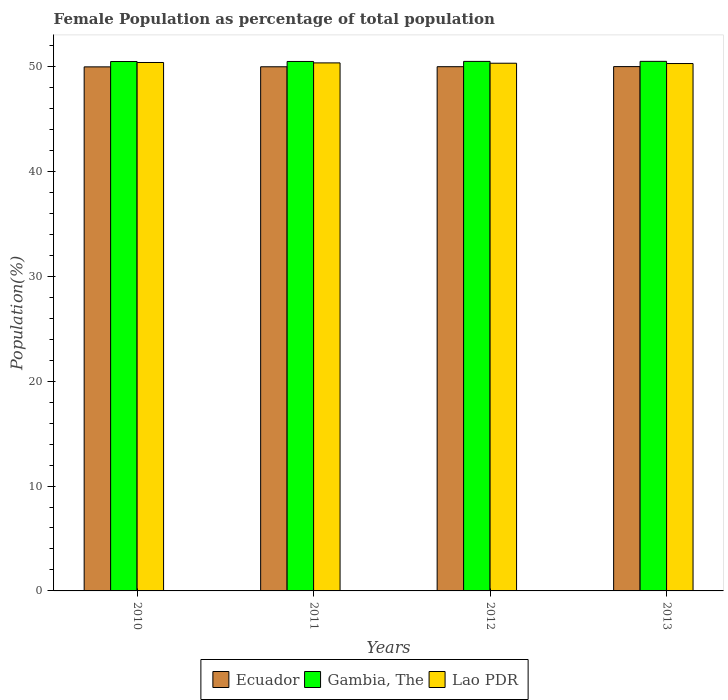How many different coloured bars are there?
Your answer should be very brief. 3. How many bars are there on the 2nd tick from the right?
Offer a terse response. 3. What is the female population in in Ecuador in 2011?
Your response must be concise. 49.98. Across all years, what is the maximum female population in in Ecuador?
Your response must be concise. 49.99. Across all years, what is the minimum female population in in Lao PDR?
Keep it short and to the point. 50.28. In which year was the female population in in Lao PDR maximum?
Your response must be concise. 2010. What is the total female population in in Gambia, The in the graph?
Provide a succinct answer. 201.94. What is the difference between the female population in in Lao PDR in 2010 and that in 2013?
Your response must be concise. 0.1. What is the difference between the female population in in Lao PDR in 2010 and the female population in in Ecuador in 2012?
Provide a succinct answer. 0.4. What is the average female population in in Gambia, The per year?
Your response must be concise. 50.48. In the year 2012, what is the difference between the female population in in Ecuador and female population in in Gambia, The?
Make the answer very short. -0.5. In how many years, is the female population in in Lao PDR greater than 20 %?
Your response must be concise. 4. What is the ratio of the female population in in Lao PDR in 2011 to that in 2012?
Your response must be concise. 1. What is the difference between the highest and the second highest female population in in Lao PDR?
Give a very brief answer. 0.04. What is the difference between the highest and the lowest female population in in Ecuador?
Offer a very short reply. 0.02. What does the 1st bar from the left in 2011 represents?
Provide a succinct answer. Ecuador. What does the 1st bar from the right in 2013 represents?
Keep it short and to the point. Lao PDR. How many bars are there?
Provide a succinct answer. 12. Are all the bars in the graph horizontal?
Keep it short and to the point. No. How many years are there in the graph?
Your response must be concise. 4. What is the difference between two consecutive major ticks on the Y-axis?
Ensure brevity in your answer.  10. Are the values on the major ticks of Y-axis written in scientific E-notation?
Your answer should be compact. No. Does the graph contain any zero values?
Give a very brief answer. No. Does the graph contain grids?
Ensure brevity in your answer.  No. Where does the legend appear in the graph?
Your answer should be very brief. Bottom center. How are the legend labels stacked?
Offer a very short reply. Horizontal. What is the title of the graph?
Give a very brief answer. Female Population as percentage of total population. What is the label or title of the Y-axis?
Provide a short and direct response. Population(%). What is the Population(%) in Ecuador in 2010?
Offer a terse response. 49.97. What is the Population(%) in Gambia, The in 2010?
Your answer should be very brief. 50.48. What is the Population(%) of Lao PDR in 2010?
Your answer should be very brief. 50.38. What is the Population(%) of Ecuador in 2011?
Ensure brevity in your answer.  49.98. What is the Population(%) of Gambia, The in 2011?
Your answer should be very brief. 50.48. What is the Population(%) in Lao PDR in 2011?
Make the answer very short. 50.35. What is the Population(%) of Ecuador in 2012?
Offer a terse response. 49.98. What is the Population(%) in Gambia, The in 2012?
Your response must be concise. 50.49. What is the Population(%) in Lao PDR in 2012?
Your answer should be very brief. 50.31. What is the Population(%) in Ecuador in 2013?
Ensure brevity in your answer.  49.99. What is the Population(%) in Gambia, The in 2013?
Provide a succinct answer. 50.49. What is the Population(%) in Lao PDR in 2013?
Give a very brief answer. 50.28. Across all years, what is the maximum Population(%) in Ecuador?
Offer a very short reply. 49.99. Across all years, what is the maximum Population(%) of Gambia, The?
Your response must be concise. 50.49. Across all years, what is the maximum Population(%) of Lao PDR?
Offer a terse response. 50.38. Across all years, what is the minimum Population(%) in Ecuador?
Ensure brevity in your answer.  49.97. Across all years, what is the minimum Population(%) of Gambia, The?
Make the answer very short. 50.48. Across all years, what is the minimum Population(%) of Lao PDR?
Provide a succinct answer. 50.28. What is the total Population(%) of Ecuador in the graph?
Your response must be concise. 199.92. What is the total Population(%) in Gambia, The in the graph?
Your response must be concise. 201.94. What is the total Population(%) of Lao PDR in the graph?
Ensure brevity in your answer.  201.33. What is the difference between the Population(%) in Ecuador in 2010 and that in 2011?
Keep it short and to the point. -0.01. What is the difference between the Population(%) in Gambia, The in 2010 and that in 2011?
Offer a terse response. -0.01. What is the difference between the Population(%) of Lao PDR in 2010 and that in 2011?
Keep it short and to the point. 0.04. What is the difference between the Population(%) in Ecuador in 2010 and that in 2012?
Offer a terse response. -0.02. What is the difference between the Population(%) in Gambia, The in 2010 and that in 2012?
Your response must be concise. -0.01. What is the difference between the Population(%) of Lao PDR in 2010 and that in 2012?
Keep it short and to the point. 0.07. What is the difference between the Population(%) in Ecuador in 2010 and that in 2013?
Keep it short and to the point. -0.03. What is the difference between the Population(%) of Gambia, The in 2010 and that in 2013?
Your answer should be very brief. -0.02. What is the difference between the Population(%) of Lao PDR in 2010 and that in 2013?
Keep it short and to the point. 0.1. What is the difference between the Population(%) of Ecuador in 2011 and that in 2012?
Give a very brief answer. -0.01. What is the difference between the Population(%) in Gambia, The in 2011 and that in 2012?
Your answer should be very brief. -0.01. What is the difference between the Population(%) in Lao PDR in 2011 and that in 2012?
Offer a terse response. 0.03. What is the difference between the Population(%) in Ecuador in 2011 and that in 2013?
Make the answer very short. -0.02. What is the difference between the Population(%) of Gambia, The in 2011 and that in 2013?
Ensure brevity in your answer.  -0.01. What is the difference between the Population(%) of Lao PDR in 2011 and that in 2013?
Provide a short and direct response. 0.06. What is the difference between the Population(%) in Ecuador in 2012 and that in 2013?
Offer a terse response. -0.01. What is the difference between the Population(%) of Gambia, The in 2012 and that in 2013?
Offer a terse response. -0. What is the difference between the Population(%) in Lao PDR in 2012 and that in 2013?
Your answer should be very brief. 0.03. What is the difference between the Population(%) of Ecuador in 2010 and the Population(%) of Gambia, The in 2011?
Give a very brief answer. -0.52. What is the difference between the Population(%) in Ecuador in 2010 and the Population(%) in Lao PDR in 2011?
Ensure brevity in your answer.  -0.38. What is the difference between the Population(%) in Gambia, The in 2010 and the Population(%) in Lao PDR in 2011?
Offer a terse response. 0.13. What is the difference between the Population(%) in Ecuador in 2010 and the Population(%) in Gambia, The in 2012?
Ensure brevity in your answer.  -0.52. What is the difference between the Population(%) of Ecuador in 2010 and the Population(%) of Lao PDR in 2012?
Ensure brevity in your answer.  -0.35. What is the difference between the Population(%) in Gambia, The in 2010 and the Population(%) in Lao PDR in 2012?
Provide a succinct answer. 0.16. What is the difference between the Population(%) in Ecuador in 2010 and the Population(%) in Gambia, The in 2013?
Your answer should be compact. -0.53. What is the difference between the Population(%) in Ecuador in 2010 and the Population(%) in Lao PDR in 2013?
Make the answer very short. -0.32. What is the difference between the Population(%) of Gambia, The in 2010 and the Population(%) of Lao PDR in 2013?
Give a very brief answer. 0.19. What is the difference between the Population(%) in Ecuador in 2011 and the Population(%) in Gambia, The in 2012?
Offer a terse response. -0.51. What is the difference between the Population(%) in Ecuador in 2011 and the Population(%) in Lao PDR in 2012?
Ensure brevity in your answer.  -0.34. What is the difference between the Population(%) in Gambia, The in 2011 and the Population(%) in Lao PDR in 2012?
Offer a terse response. 0.17. What is the difference between the Population(%) of Ecuador in 2011 and the Population(%) of Gambia, The in 2013?
Ensure brevity in your answer.  -0.52. What is the difference between the Population(%) in Ecuador in 2011 and the Population(%) in Lao PDR in 2013?
Give a very brief answer. -0.31. What is the difference between the Population(%) in Gambia, The in 2011 and the Population(%) in Lao PDR in 2013?
Provide a short and direct response. 0.2. What is the difference between the Population(%) in Ecuador in 2012 and the Population(%) in Gambia, The in 2013?
Your answer should be compact. -0.51. What is the difference between the Population(%) in Ecuador in 2012 and the Population(%) in Lao PDR in 2013?
Ensure brevity in your answer.  -0.3. What is the difference between the Population(%) in Gambia, The in 2012 and the Population(%) in Lao PDR in 2013?
Offer a very short reply. 0.2. What is the average Population(%) in Ecuador per year?
Your answer should be very brief. 49.98. What is the average Population(%) of Gambia, The per year?
Provide a short and direct response. 50.48. What is the average Population(%) of Lao PDR per year?
Your answer should be compact. 50.33. In the year 2010, what is the difference between the Population(%) of Ecuador and Population(%) of Gambia, The?
Your answer should be very brief. -0.51. In the year 2010, what is the difference between the Population(%) in Ecuador and Population(%) in Lao PDR?
Offer a terse response. -0.42. In the year 2010, what is the difference between the Population(%) of Gambia, The and Population(%) of Lao PDR?
Offer a terse response. 0.09. In the year 2011, what is the difference between the Population(%) of Ecuador and Population(%) of Gambia, The?
Ensure brevity in your answer.  -0.51. In the year 2011, what is the difference between the Population(%) of Ecuador and Population(%) of Lao PDR?
Offer a very short reply. -0.37. In the year 2011, what is the difference between the Population(%) in Gambia, The and Population(%) in Lao PDR?
Give a very brief answer. 0.14. In the year 2012, what is the difference between the Population(%) of Ecuador and Population(%) of Gambia, The?
Your response must be concise. -0.5. In the year 2012, what is the difference between the Population(%) of Ecuador and Population(%) of Lao PDR?
Offer a terse response. -0.33. In the year 2012, what is the difference between the Population(%) in Gambia, The and Population(%) in Lao PDR?
Your response must be concise. 0.17. In the year 2013, what is the difference between the Population(%) in Ecuador and Population(%) in Gambia, The?
Your answer should be compact. -0.5. In the year 2013, what is the difference between the Population(%) in Ecuador and Population(%) in Lao PDR?
Offer a very short reply. -0.29. In the year 2013, what is the difference between the Population(%) of Gambia, The and Population(%) of Lao PDR?
Your answer should be very brief. 0.21. What is the ratio of the Population(%) of Gambia, The in 2010 to that in 2012?
Give a very brief answer. 1. What is the ratio of the Population(%) of Lao PDR in 2010 to that in 2012?
Your answer should be very brief. 1. What is the ratio of the Population(%) in Ecuador in 2010 to that in 2013?
Offer a terse response. 1. What is the ratio of the Population(%) of Gambia, The in 2011 to that in 2012?
Keep it short and to the point. 1. What is the ratio of the Population(%) in Ecuador in 2011 to that in 2013?
Keep it short and to the point. 1. What is the ratio of the Population(%) in Gambia, The in 2011 to that in 2013?
Keep it short and to the point. 1. What is the ratio of the Population(%) of Lao PDR in 2011 to that in 2013?
Make the answer very short. 1. What is the ratio of the Population(%) of Gambia, The in 2012 to that in 2013?
Keep it short and to the point. 1. What is the ratio of the Population(%) in Lao PDR in 2012 to that in 2013?
Your response must be concise. 1. What is the difference between the highest and the second highest Population(%) in Ecuador?
Your answer should be very brief. 0.01. What is the difference between the highest and the second highest Population(%) in Gambia, The?
Make the answer very short. 0. What is the difference between the highest and the second highest Population(%) in Lao PDR?
Provide a short and direct response. 0.04. What is the difference between the highest and the lowest Population(%) of Ecuador?
Offer a very short reply. 0.03. What is the difference between the highest and the lowest Population(%) in Gambia, The?
Keep it short and to the point. 0.02. What is the difference between the highest and the lowest Population(%) in Lao PDR?
Your response must be concise. 0.1. 